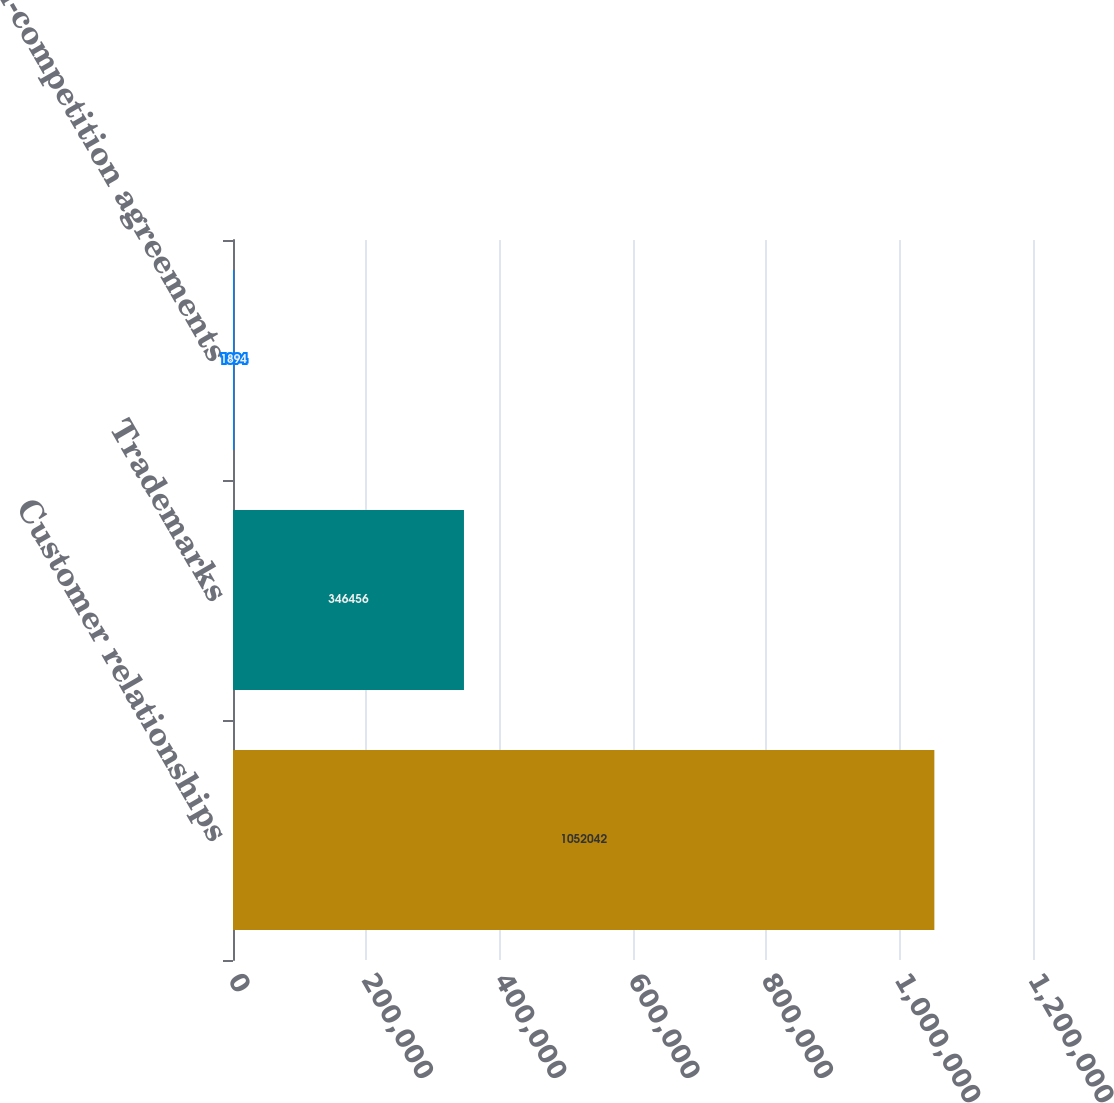<chart> <loc_0><loc_0><loc_500><loc_500><bar_chart><fcel>Customer relationships<fcel>Trademarks<fcel>Non-competition agreements<nl><fcel>1.05204e+06<fcel>346456<fcel>1894<nl></chart> 